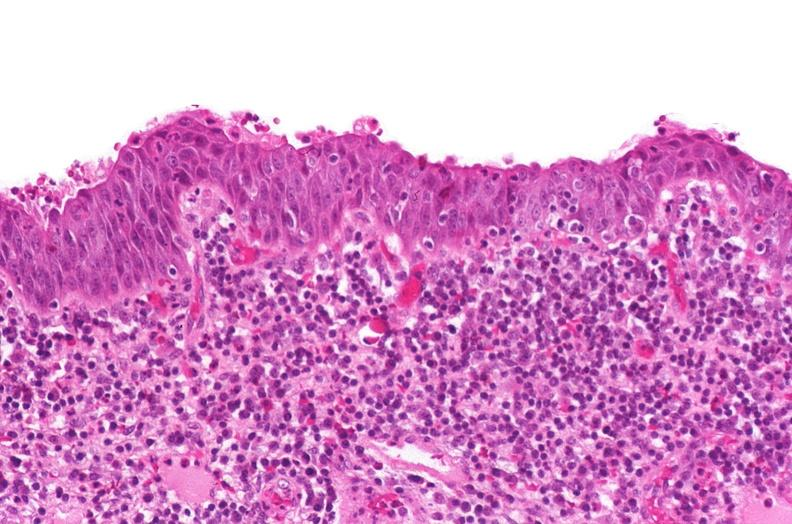s urinary present?
Answer the question using a single word or phrase. Yes 